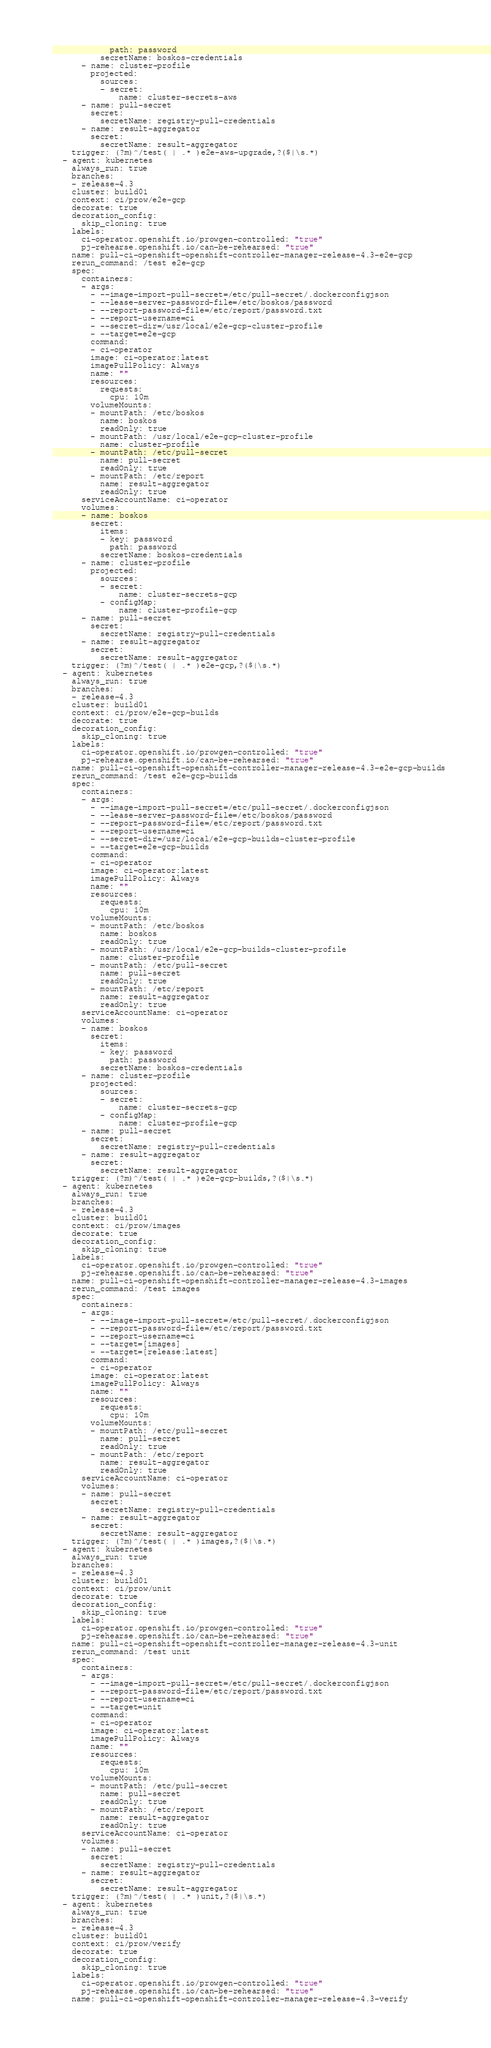Convert code to text. <code><loc_0><loc_0><loc_500><loc_500><_YAML_>            path: password
          secretName: boskos-credentials
      - name: cluster-profile
        projected:
          sources:
          - secret:
              name: cluster-secrets-aws
      - name: pull-secret
        secret:
          secretName: registry-pull-credentials
      - name: result-aggregator
        secret:
          secretName: result-aggregator
    trigger: (?m)^/test( | .* )e2e-aws-upgrade,?($|\s.*)
  - agent: kubernetes
    always_run: true
    branches:
    - release-4.3
    cluster: build01
    context: ci/prow/e2e-gcp
    decorate: true
    decoration_config:
      skip_cloning: true
    labels:
      ci-operator.openshift.io/prowgen-controlled: "true"
      pj-rehearse.openshift.io/can-be-rehearsed: "true"
    name: pull-ci-openshift-openshift-controller-manager-release-4.3-e2e-gcp
    rerun_command: /test e2e-gcp
    spec:
      containers:
      - args:
        - --image-import-pull-secret=/etc/pull-secret/.dockerconfigjson
        - --lease-server-password-file=/etc/boskos/password
        - --report-password-file=/etc/report/password.txt
        - --report-username=ci
        - --secret-dir=/usr/local/e2e-gcp-cluster-profile
        - --target=e2e-gcp
        command:
        - ci-operator
        image: ci-operator:latest
        imagePullPolicy: Always
        name: ""
        resources:
          requests:
            cpu: 10m
        volumeMounts:
        - mountPath: /etc/boskos
          name: boskos
          readOnly: true
        - mountPath: /usr/local/e2e-gcp-cluster-profile
          name: cluster-profile
        - mountPath: /etc/pull-secret
          name: pull-secret
          readOnly: true
        - mountPath: /etc/report
          name: result-aggregator
          readOnly: true
      serviceAccountName: ci-operator
      volumes:
      - name: boskos
        secret:
          items:
          - key: password
            path: password
          secretName: boskos-credentials
      - name: cluster-profile
        projected:
          sources:
          - secret:
              name: cluster-secrets-gcp
          - configMap:
              name: cluster-profile-gcp
      - name: pull-secret
        secret:
          secretName: registry-pull-credentials
      - name: result-aggregator
        secret:
          secretName: result-aggregator
    trigger: (?m)^/test( | .* )e2e-gcp,?($|\s.*)
  - agent: kubernetes
    always_run: true
    branches:
    - release-4.3
    cluster: build01
    context: ci/prow/e2e-gcp-builds
    decorate: true
    decoration_config:
      skip_cloning: true
    labels:
      ci-operator.openshift.io/prowgen-controlled: "true"
      pj-rehearse.openshift.io/can-be-rehearsed: "true"
    name: pull-ci-openshift-openshift-controller-manager-release-4.3-e2e-gcp-builds
    rerun_command: /test e2e-gcp-builds
    spec:
      containers:
      - args:
        - --image-import-pull-secret=/etc/pull-secret/.dockerconfigjson
        - --lease-server-password-file=/etc/boskos/password
        - --report-password-file=/etc/report/password.txt
        - --report-username=ci
        - --secret-dir=/usr/local/e2e-gcp-builds-cluster-profile
        - --target=e2e-gcp-builds
        command:
        - ci-operator
        image: ci-operator:latest
        imagePullPolicy: Always
        name: ""
        resources:
          requests:
            cpu: 10m
        volumeMounts:
        - mountPath: /etc/boskos
          name: boskos
          readOnly: true
        - mountPath: /usr/local/e2e-gcp-builds-cluster-profile
          name: cluster-profile
        - mountPath: /etc/pull-secret
          name: pull-secret
          readOnly: true
        - mountPath: /etc/report
          name: result-aggregator
          readOnly: true
      serviceAccountName: ci-operator
      volumes:
      - name: boskos
        secret:
          items:
          - key: password
            path: password
          secretName: boskos-credentials
      - name: cluster-profile
        projected:
          sources:
          - secret:
              name: cluster-secrets-gcp
          - configMap:
              name: cluster-profile-gcp
      - name: pull-secret
        secret:
          secretName: registry-pull-credentials
      - name: result-aggregator
        secret:
          secretName: result-aggregator
    trigger: (?m)^/test( | .* )e2e-gcp-builds,?($|\s.*)
  - agent: kubernetes
    always_run: true
    branches:
    - release-4.3
    cluster: build01
    context: ci/prow/images
    decorate: true
    decoration_config:
      skip_cloning: true
    labels:
      ci-operator.openshift.io/prowgen-controlled: "true"
      pj-rehearse.openshift.io/can-be-rehearsed: "true"
    name: pull-ci-openshift-openshift-controller-manager-release-4.3-images
    rerun_command: /test images
    spec:
      containers:
      - args:
        - --image-import-pull-secret=/etc/pull-secret/.dockerconfigjson
        - --report-password-file=/etc/report/password.txt
        - --report-username=ci
        - --target=[images]
        - --target=[release:latest]
        command:
        - ci-operator
        image: ci-operator:latest
        imagePullPolicy: Always
        name: ""
        resources:
          requests:
            cpu: 10m
        volumeMounts:
        - mountPath: /etc/pull-secret
          name: pull-secret
          readOnly: true
        - mountPath: /etc/report
          name: result-aggregator
          readOnly: true
      serviceAccountName: ci-operator
      volumes:
      - name: pull-secret
        secret:
          secretName: registry-pull-credentials
      - name: result-aggregator
        secret:
          secretName: result-aggregator
    trigger: (?m)^/test( | .* )images,?($|\s.*)
  - agent: kubernetes
    always_run: true
    branches:
    - release-4.3
    cluster: build01
    context: ci/prow/unit
    decorate: true
    decoration_config:
      skip_cloning: true
    labels:
      ci-operator.openshift.io/prowgen-controlled: "true"
      pj-rehearse.openshift.io/can-be-rehearsed: "true"
    name: pull-ci-openshift-openshift-controller-manager-release-4.3-unit
    rerun_command: /test unit
    spec:
      containers:
      - args:
        - --image-import-pull-secret=/etc/pull-secret/.dockerconfigjson
        - --report-password-file=/etc/report/password.txt
        - --report-username=ci
        - --target=unit
        command:
        - ci-operator
        image: ci-operator:latest
        imagePullPolicy: Always
        name: ""
        resources:
          requests:
            cpu: 10m
        volumeMounts:
        - mountPath: /etc/pull-secret
          name: pull-secret
          readOnly: true
        - mountPath: /etc/report
          name: result-aggregator
          readOnly: true
      serviceAccountName: ci-operator
      volumes:
      - name: pull-secret
        secret:
          secretName: registry-pull-credentials
      - name: result-aggregator
        secret:
          secretName: result-aggregator
    trigger: (?m)^/test( | .* )unit,?($|\s.*)
  - agent: kubernetes
    always_run: true
    branches:
    - release-4.3
    cluster: build01
    context: ci/prow/verify
    decorate: true
    decoration_config:
      skip_cloning: true
    labels:
      ci-operator.openshift.io/prowgen-controlled: "true"
      pj-rehearse.openshift.io/can-be-rehearsed: "true"
    name: pull-ci-openshift-openshift-controller-manager-release-4.3-verify</code> 